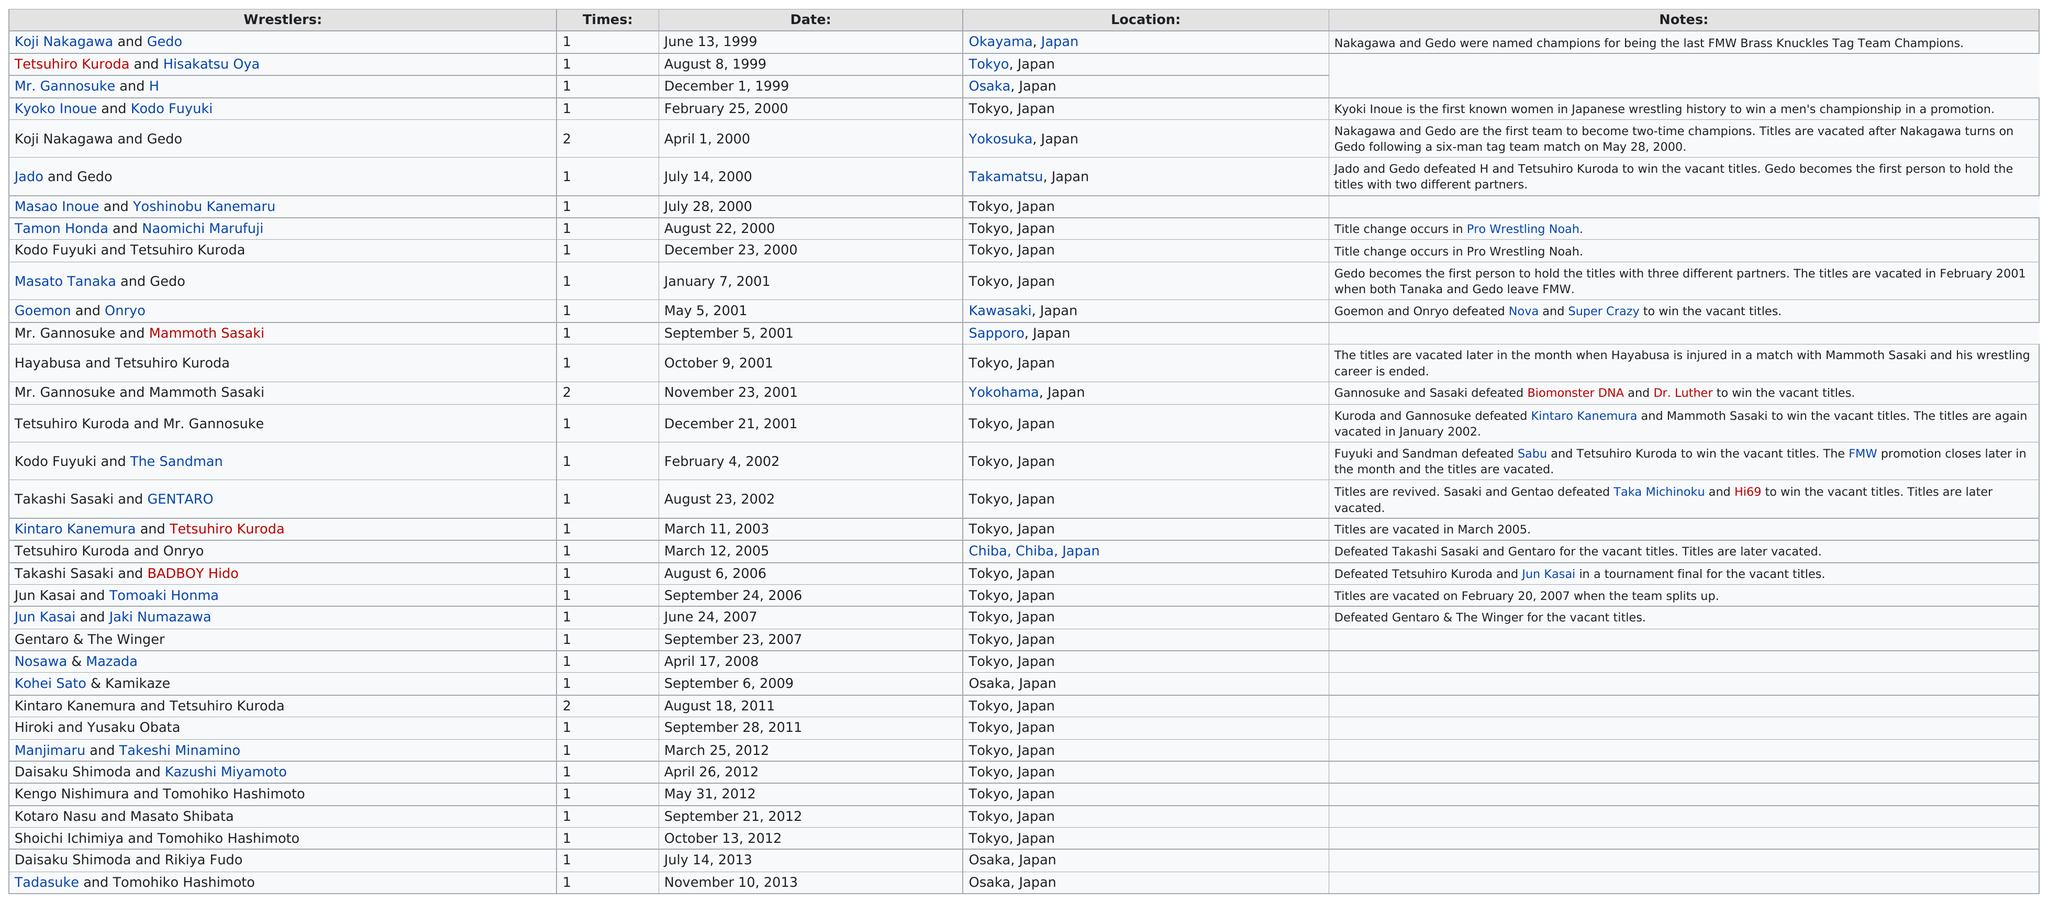Give some essential details in this illustration. The location that was used the most often was Tokyo, Japan. The last date listed is November 10, 2013. There are a total of 34 wrestler groups listed. It has been determined that wrestlers Kodo Fuyuki and The Sandman share the same year listed for their date of birth as Takashi Sasaki and GENTARO. The location difference between Koji Nakagawa and Gedo is Yokosuka, Japan, while the location difference between Jado and Gedo is Takamatsu, Japan. 